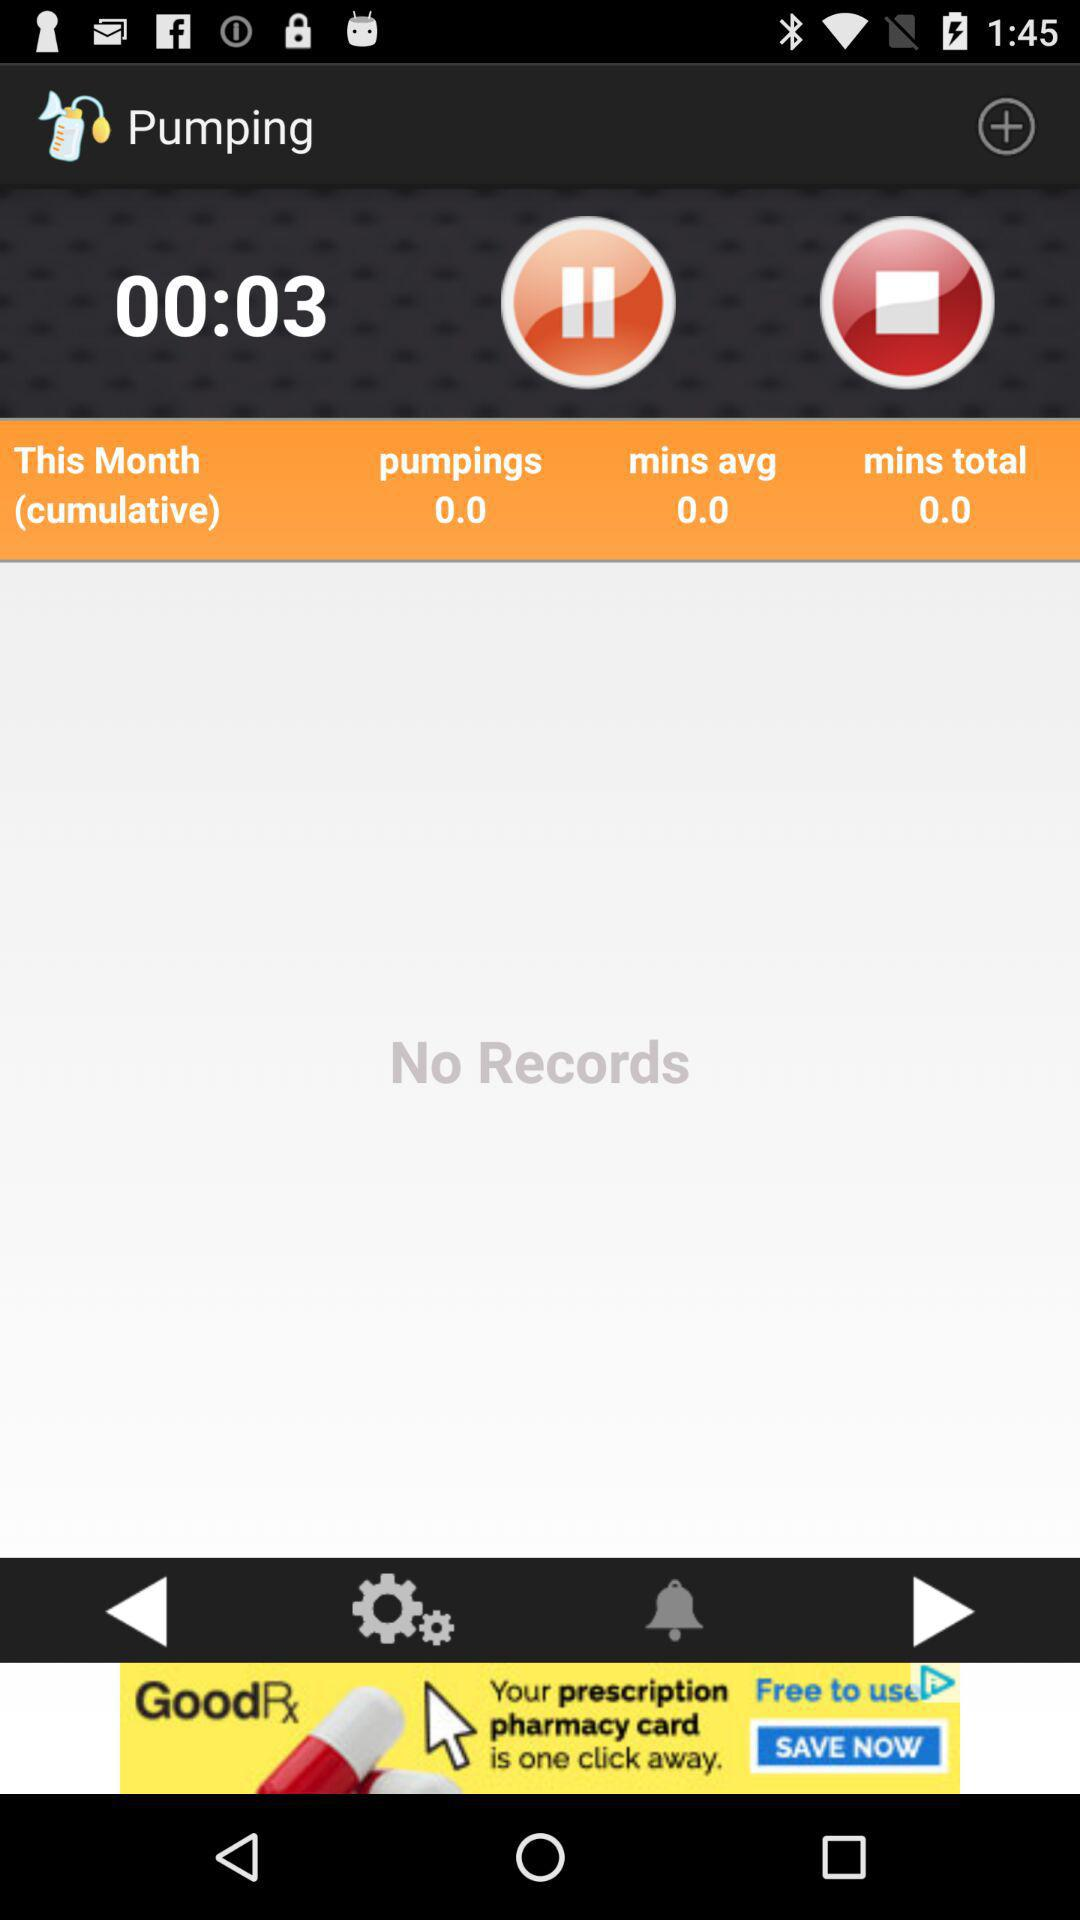What is the duration mentioned for pumpings? The mentioned duration for pumpings is 0 seconds. 